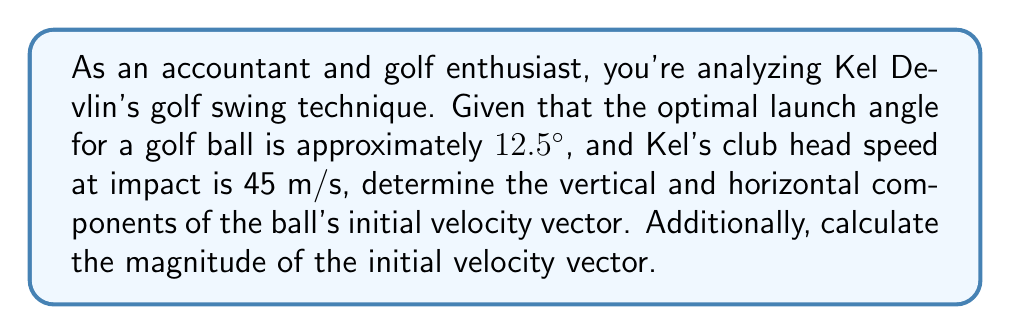Show me your answer to this math problem. To solve this problem, we'll use trigonometry and vector decomposition. Let's break it down step by step:

1. Given information:
   - Optimal launch angle: $\theta = 12.5°$
   - Club head speed at impact: $v = 45$ m/s

2. Decompose the velocity vector into its vertical and horizontal components:
   - Vertical component: $v_y = v \sin(\theta)$
   - Horizontal component: $v_x = v \cos(\theta)$

3. Calculate the vertical component:
   $$v_y = 45 \sin(12.5°) = 45 \cdot 0.2164 = 9.738 \text{ m/s}$$

4. Calculate the horizontal component:
   $$v_x = 45 \cos(12.5°) = 45 \cdot 0.9763 = 43.933 \text{ m/s}$$

5. The initial velocity vector can be expressed as:
   $$\vec{v} = (43.933, 9.738)$$

6. To calculate the magnitude of the initial velocity vector, use the Pythagorean theorem:
   $$|\vec{v}| = \sqrt{v_x^2 + v_y^2} = \sqrt{43.933^2 + 9.738^2} = 45 \text{ m/s}$$

   Note that this matches the given club head speed, which is expected as we assumed perfect energy transfer from the club to the ball.

[asy]
import geometry;

size(200);
draw((0,0)--(100,0), arrow=Arrow(TeXHead));
draw((0,0)--(0,50), arrow=Arrow(TeXHead));
draw((0,0)--(90,20), arrow=Arrow(TeXHead));
label("$v_x$", (50,-5));
label("$v_y$", (-5,25));
label("$\vec{v}$", (45,15));
label("$\theta$", (10,5));
draw(arc((0,0),10,0,12.5));
[/asy]
Answer: Vertical component: $v_y = 9.738 \text{ m/s}$
Horizontal component: $v_x = 43.933 \text{ m/s}$
Initial velocity vector: $\vec{v} = (43.933, 9.738)$
Magnitude of initial velocity vector: $|\vec{v}| = 45 \text{ m/s}$ 